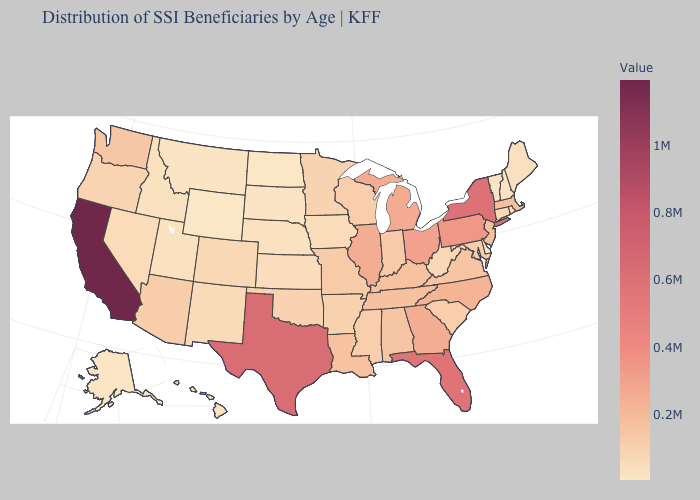Is the legend a continuous bar?
Quick response, please. Yes. Which states have the highest value in the USA?
Concise answer only. California. Among the states that border Maryland , does Pennsylvania have the lowest value?
Give a very brief answer. No. Is the legend a continuous bar?
Answer briefly. Yes. Among the states that border Arkansas , which have the lowest value?
Write a very short answer. Oklahoma. Does Nebraska have the highest value in the USA?
Give a very brief answer. No. Among the states that border California , which have the highest value?
Give a very brief answer. Arizona. Does Louisiana have the highest value in the South?
Short answer required. No. Does Idaho have a lower value than Kentucky?
Give a very brief answer. Yes. 